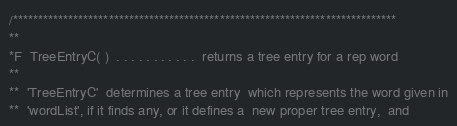<code> <loc_0><loc_0><loc_500><loc_500><_C_>
/****************************************************************************
**
*F  TreeEntryC( )  . . . . . . . . . . .  returns a tree entry for a rep word
**
**  'TreeEntryC'  determines a tree entry  which represents the word given in
**  'wordList', if it finds any, or it defines a  new proper tree entry,  and</code> 